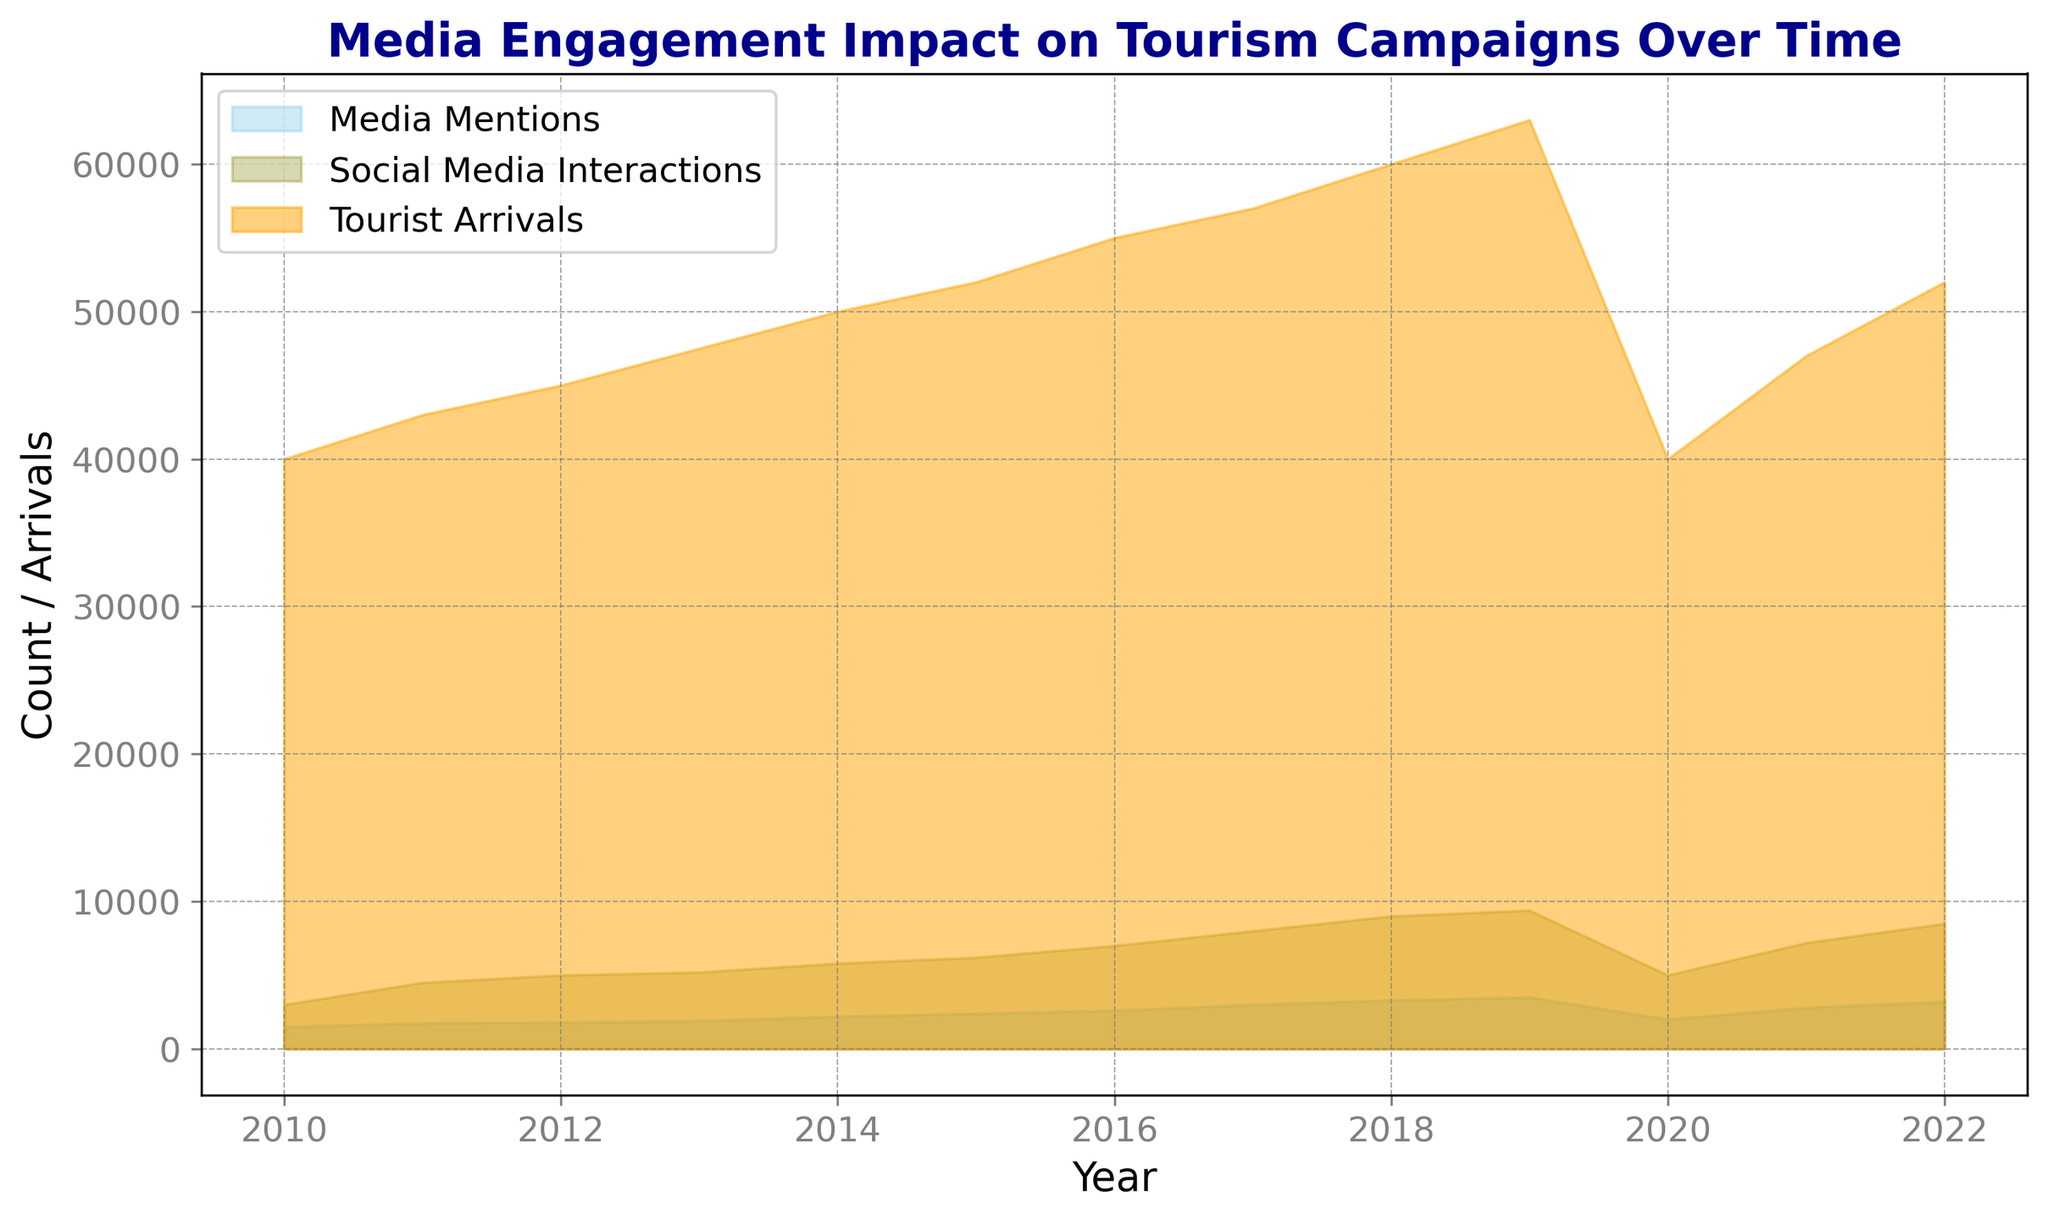How did tourist arrivals change from 2019 to 2020? From 2019 to 2020, tourist arrivals decreased from 63,000 to 40,000. This is indicated by a drop in the height of the orange area on the chart.
Answer: Decreased Which year had the highest number of social media interactions? The greenish-olive area shows that 2019 had the highest number of social media interactions, peaking at 9400.
Answer: 2019 Compare the number of media mentions in 2020 versus 2019. Which year had more? By examining the skyblue area, we observe that 2019 had 3500 media mentions, whereas 2020 had only 2000.
Answer: 2019 In which year was the gap between tourist arrivals and social media interactions the smallest? By comparing the orange and olive areas, the gap appears smallest in 2020 as both areas are closer together compared to other years.
Answer: 2020 What was the trend of tourist arrivals from 2010 to 2019? The orange area shows a consistently increasing trend from 2010 (40,000) to 2019 (63,000).
Answer: Increasing During which year did media mentions see a significant drop, and how is it visually represented? Media mentions saw a significant drop in 2020, represented visually by a sharp decrease in the height of the skyblue area.
Answer: 2020 What was the minimum number of social media interactions recorded between 2010 and 2022? The greenish-olive area indicates the minimum was 3000 in 2010.
Answer: 3000 Calculate the difference in tourist arrivals between 2011 and 2014. 2011 had 43,000 and 2014 had 50,000 arrivals. The difference is 50,000 - 43,000 = 7000.
Answer: 7000 Compare the trends in media mentions and social media interactions from 2017 to 2019. What do you notice? Both skyblue (media mentions) and olive (social media interactions) areas show an upward trend from 2017 to 2019.
Answer: Both increased What visible change occurred in tourist arrivals between 2019 and 2022? The orange area shows a drop in tourist arrivals from 63,000 in 2019 to 40,000 in 2020, then a gradual increase to 52,000 by 2022.
Answer: Dropped then increased 